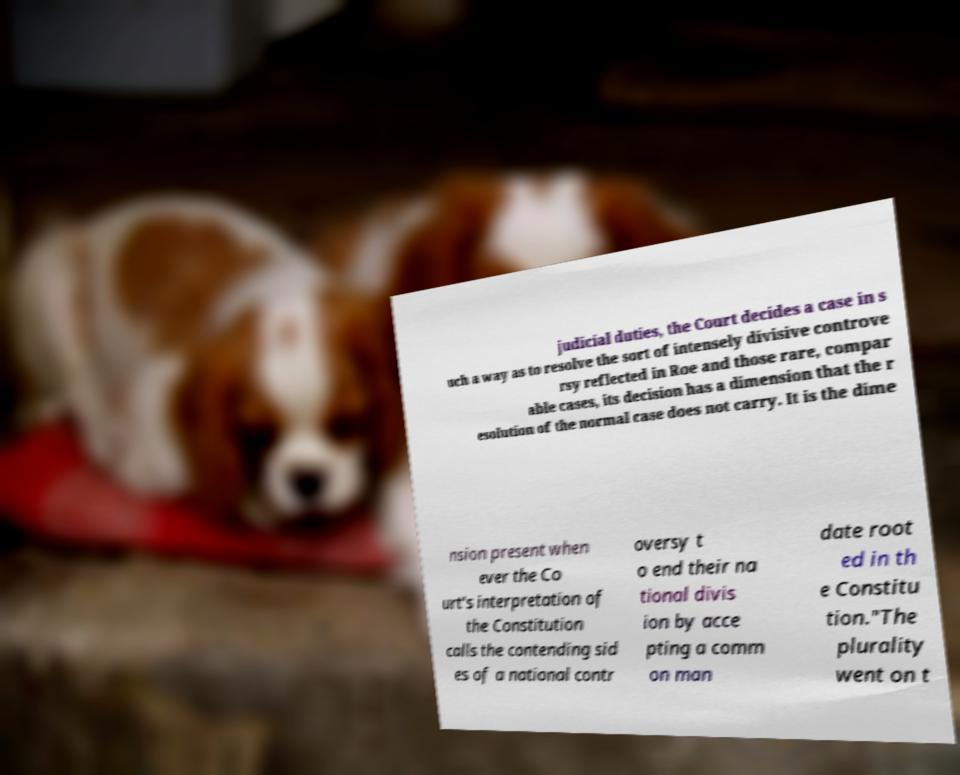Could you assist in decoding the text presented in this image and type it out clearly? judicial duties, the Court decides a case in s uch a way as to resolve the sort of intensely divisive controve rsy reflected in Roe and those rare, compar able cases, its decision has a dimension that the r esolution of the normal case does not carry. It is the dime nsion present when ever the Co urt's interpretation of the Constitution calls the contending sid es of a national contr oversy t o end their na tional divis ion by acce pting a comm on man date root ed in th e Constitu tion."The plurality went on t 